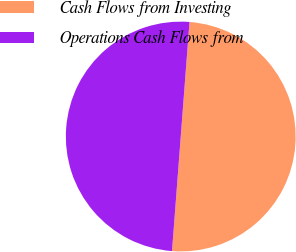<chart> <loc_0><loc_0><loc_500><loc_500><pie_chart><fcel>Cash Flows from Investing<fcel>Operations Cash Flows from<nl><fcel>50.0%<fcel>50.0%<nl></chart> 